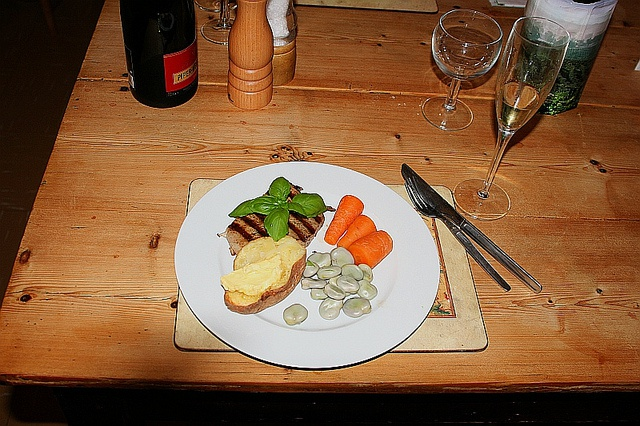Describe the objects in this image and their specific colors. I can see dining table in black, brown, maroon, and tan tones, wine glass in black, brown, and maroon tones, bottle in black, maroon, and brown tones, wine glass in black, maroon, and brown tones, and bottle in black, darkgray, and gray tones in this image. 